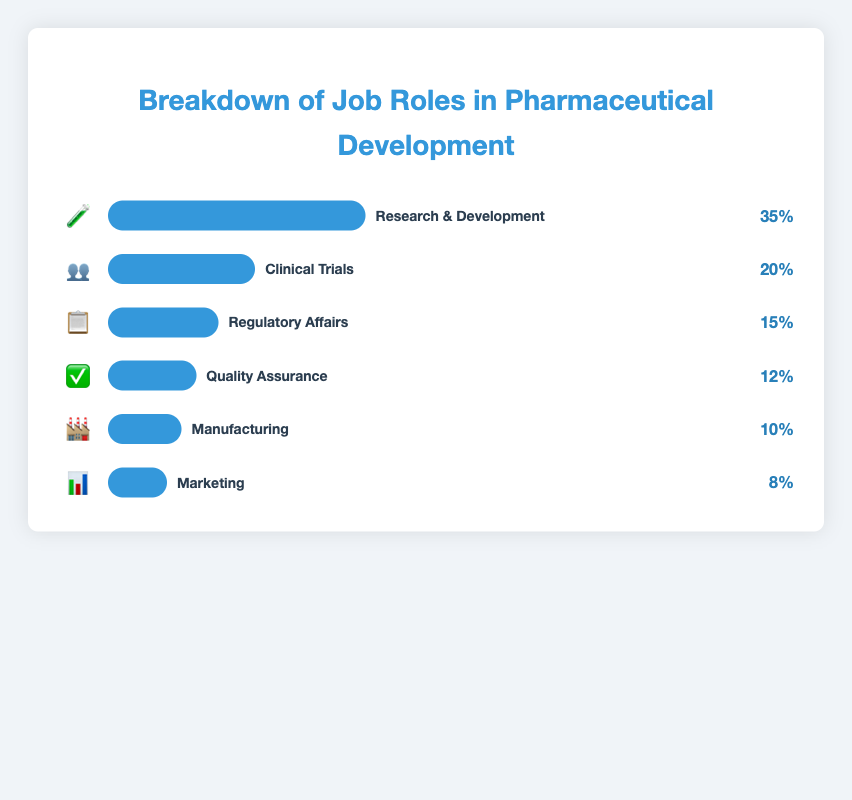What is the title of the figure? The title of the figure is given at the top of the visualization. It reads "Breakdown of Job Roles in Pharmaceutical Development."
Answer: Breakdown of Job Roles in Pharmaceutical Development Which department has the highest percentage of job roles? The department with the highest percentage is indicated by the length of the bar. The longest bar corresponds to "Research & Development."
Answer: Research & Development What percentage of job roles does the Clinical Trials department hold? The percentage is shown to the right of the bar corresponding to Clinical Trials. It reads "20%."
Answer: 20% How many departments are represented in the figure? By counting each bar and corresponding label, we can determine that there are six departments shown in the chart.
Answer: 6 What is the combined percentage of job roles in Quality Assurance and Manufacturing? Quality Assurance holds 12%, and Manufacturing holds 10%. Adding these percentages gives 12% + 10% = 22%.
Answer: 22% Which department is represented by the emoji "🏭"? The emoji "🏭" is next to the label "Manufacturing" in the figure.
Answer: Manufacturing What is the difference in job roles percentage between Regulatory Affairs and Marketing? Regulatory Affairs has a percentage of 15%, and Marketing has 8%. The difference is 15% - 8% = 7%.
Answer: 7% Is the percentage of job roles in Marketing greater than in Manufacturing? The percentage for Marketing (8%) is less than that for Manufacturing (10%).
Answer: No How do the job roles in Regulatory Affairs compare to those in Quality Assurance in terms of percentage? Regulatory Affairs has 15%, and Quality Assurance has 12%. Comparing them, 15% is greater than 12%.
Answer: Regulatory Affairs has a higher percentage Sum all the job roles percentages to check if they add up to 100%. Adding up all the percentages: 35% (R&D) + 20% (Clinical Trials) + 15% (Regulatory Affairs) + 12% (Quality Assurance) + 10% (Manufacturing) + 8% (Marketing) = 100%.
Answer: 100% 